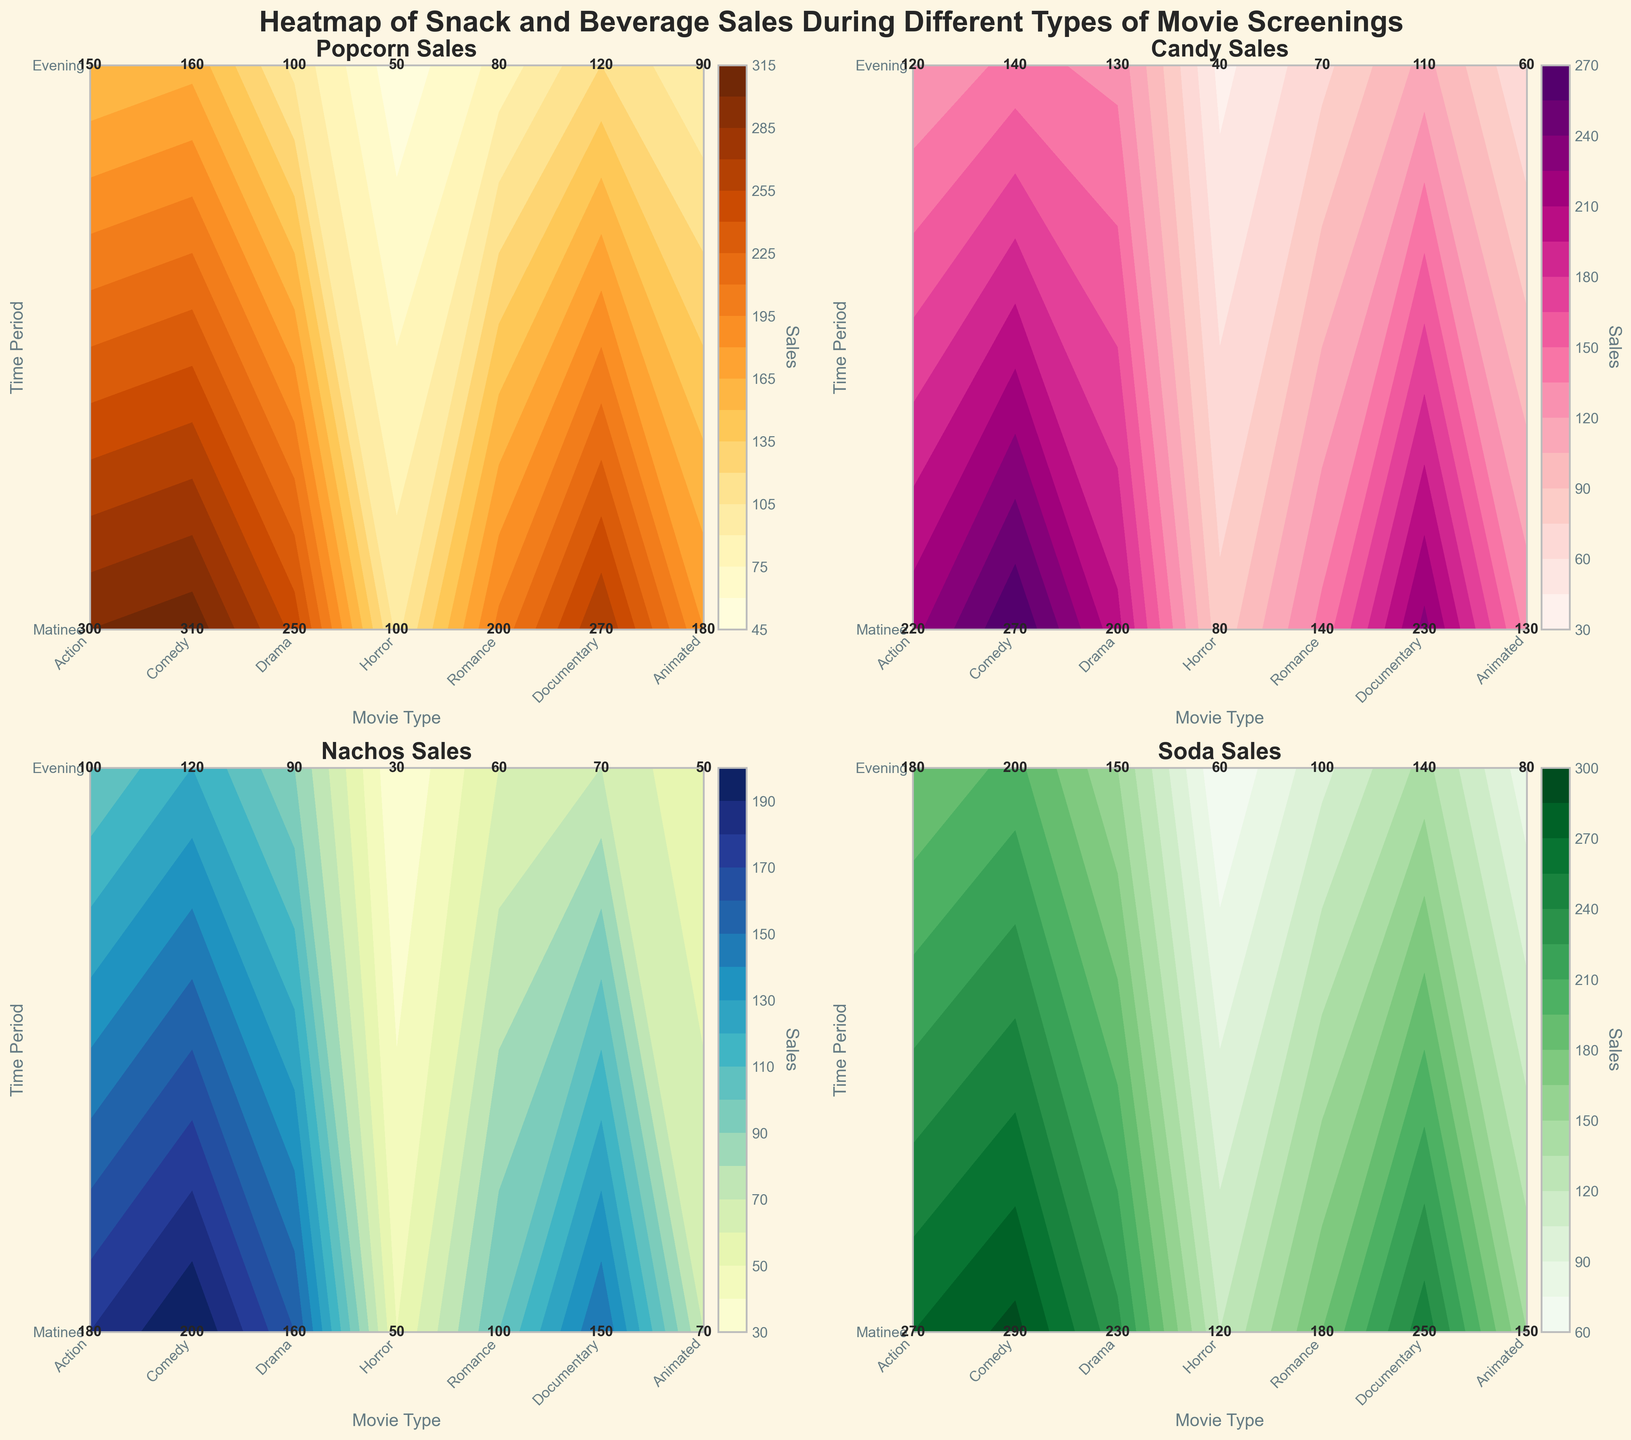Which movie type has the highest evening popcorn sales? Refer to the Popcorn Sales plot, look at the Evening row, and find the highest value. The movie type corresponding to this value is the one with the highest evening popcorn sales. The highest value is 310 for Animated movies.
Answer: Animated What is the total soda sales during matinee screenings for all movie types combined? Look at the Soda Sales plot, locate the Matinee row, and sum all the values in this row. The values are 180 + 150 + 100 + 140 + 80 + 60 + 200, which total to 910.
Answer: 910 Which time period shows higher candy sales for horror movies, matinee or evening? Refer to the Candy Sales plot, look at the cells corresponding to Horror movies in both Matinee and Evening rows. Compare the values 110 (Matinee) and 230 (Evening). The evening sales are higher.
Answer: Evening For which movie type are nachos least purchased during evening screenings? Refer to the Nachos Sales plot, locate the Evening row, and identify the lowest value. The lowest value is 50, which corresponds to Documentary movies.
Answer: Documentary What is the average popcorn sales for drama movies across both time periods? Refer to the Popcorn Sales plot, find the cells for Drama movies in both Matinee and Evening rows, which are 80 and 200. Calculate the average (80 + 200) / 2 = 140.
Answer: 140 Which snack has the highest mean sales during action movie evenings? First, identify the sales values for all snacks during evening action movies from all plots: Popcorn (300), Candy (220), Nachos (180), Soda (270). Calculate the mean for each: Popcorn 300, Candy 220, Nachos 180, Soda 270. Soda has the highest mean sales.
Answer: Soda Which has a larger range of sales values during matinee screenings: popcorn or soda? For Matinee screenings, identify the range for Popcorn (150 - 50 = 100) and for Soda (200 - 60 = 140) by finding the difference between the highest and lowest sales values. Soda has the larger range.
Answer: Soda Which movie type has the smallest difference in candy sales between matinee and evening showings? Refer to the Candy Sales plot, find the difference for each movie type between Evening and Matinee showings. The smallest difference is for Documentary movies (80 - 40 = 40).
Answer: Documentary 